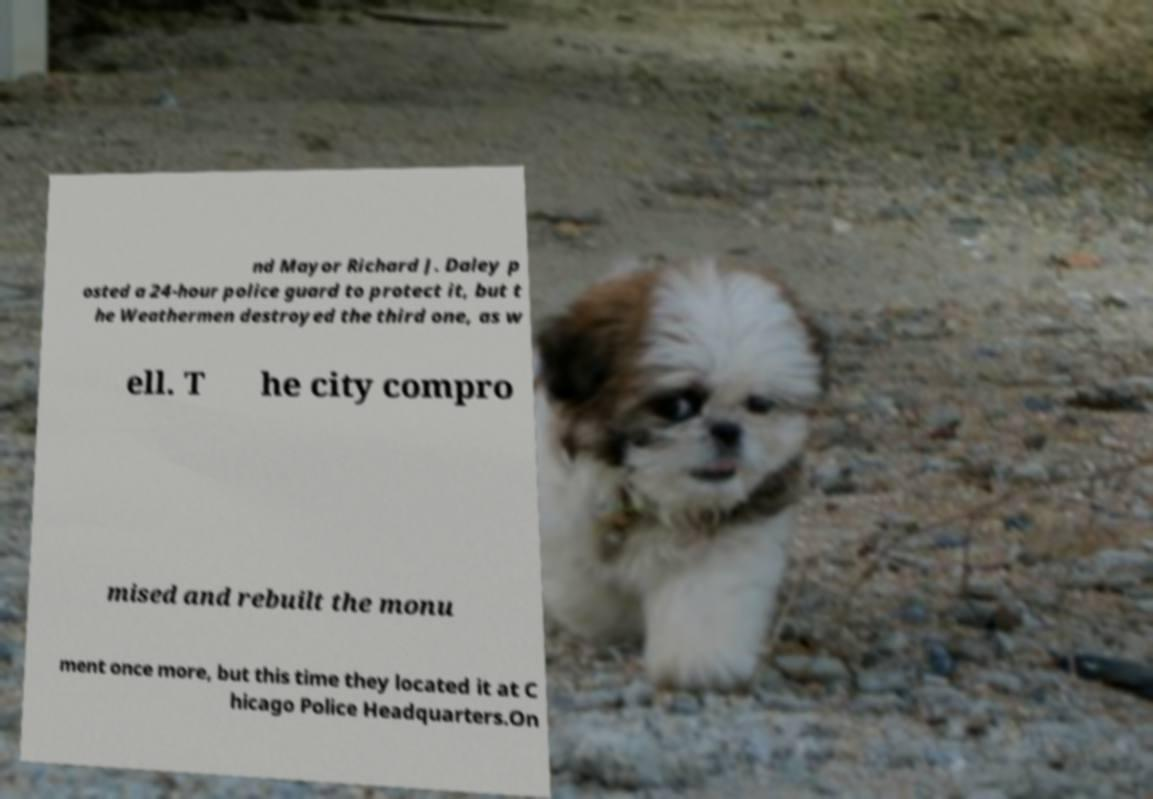Can you read and provide the text displayed in the image?This photo seems to have some interesting text. Can you extract and type it out for me? nd Mayor Richard J. Daley p osted a 24-hour police guard to protect it, but t he Weathermen destroyed the third one, as w ell. T he city compro mised and rebuilt the monu ment once more, but this time they located it at C hicago Police Headquarters.On 